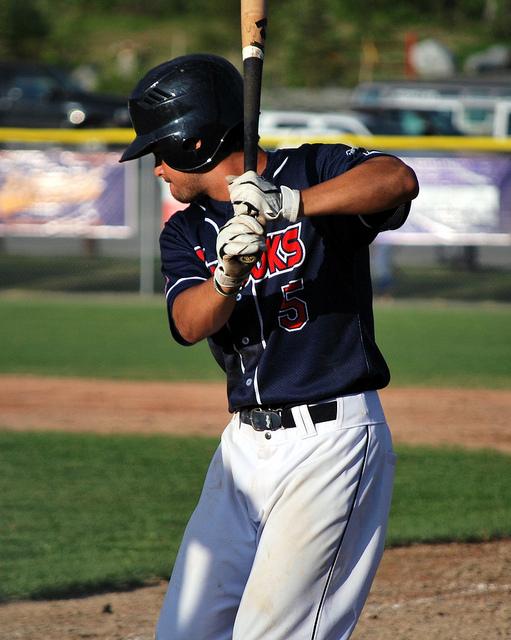What sport does the man play?
Give a very brief answer. Baseball. Is this the man's first time playing baseball?
Answer briefly. No. What number is on the man's shirt?
Keep it brief. 5. 